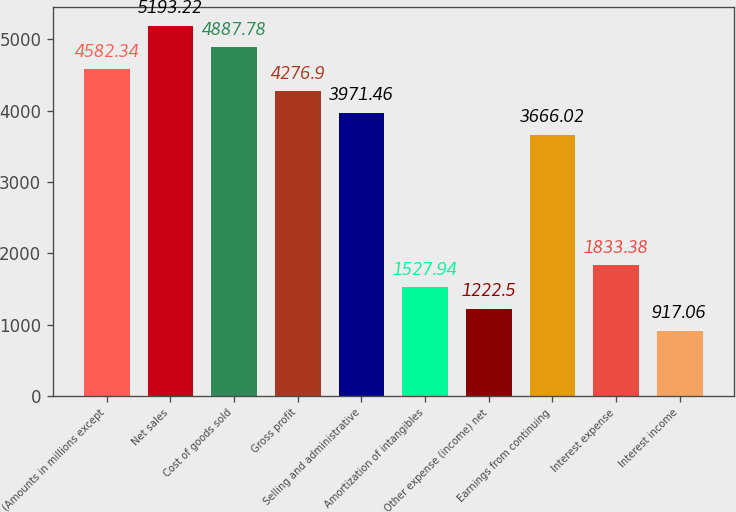<chart> <loc_0><loc_0><loc_500><loc_500><bar_chart><fcel>(Amounts in millions except<fcel>Net sales<fcel>Cost of goods sold<fcel>Gross profit<fcel>Selling and administrative<fcel>Amortization of intangibles<fcel>Other expense (income) net<fcel>Earnings from continuing<fcel>Interest expense<fcel>Interest income<nl><fcel>4582.34<fcel>5193.22<fcel>4887.78<fcel>4276.9<fcel>3971.46<fcel>1527.94<fcel>1222.5<fcel>3666.02<fcel>1833.38<fcel>917.06<nl></chart> 